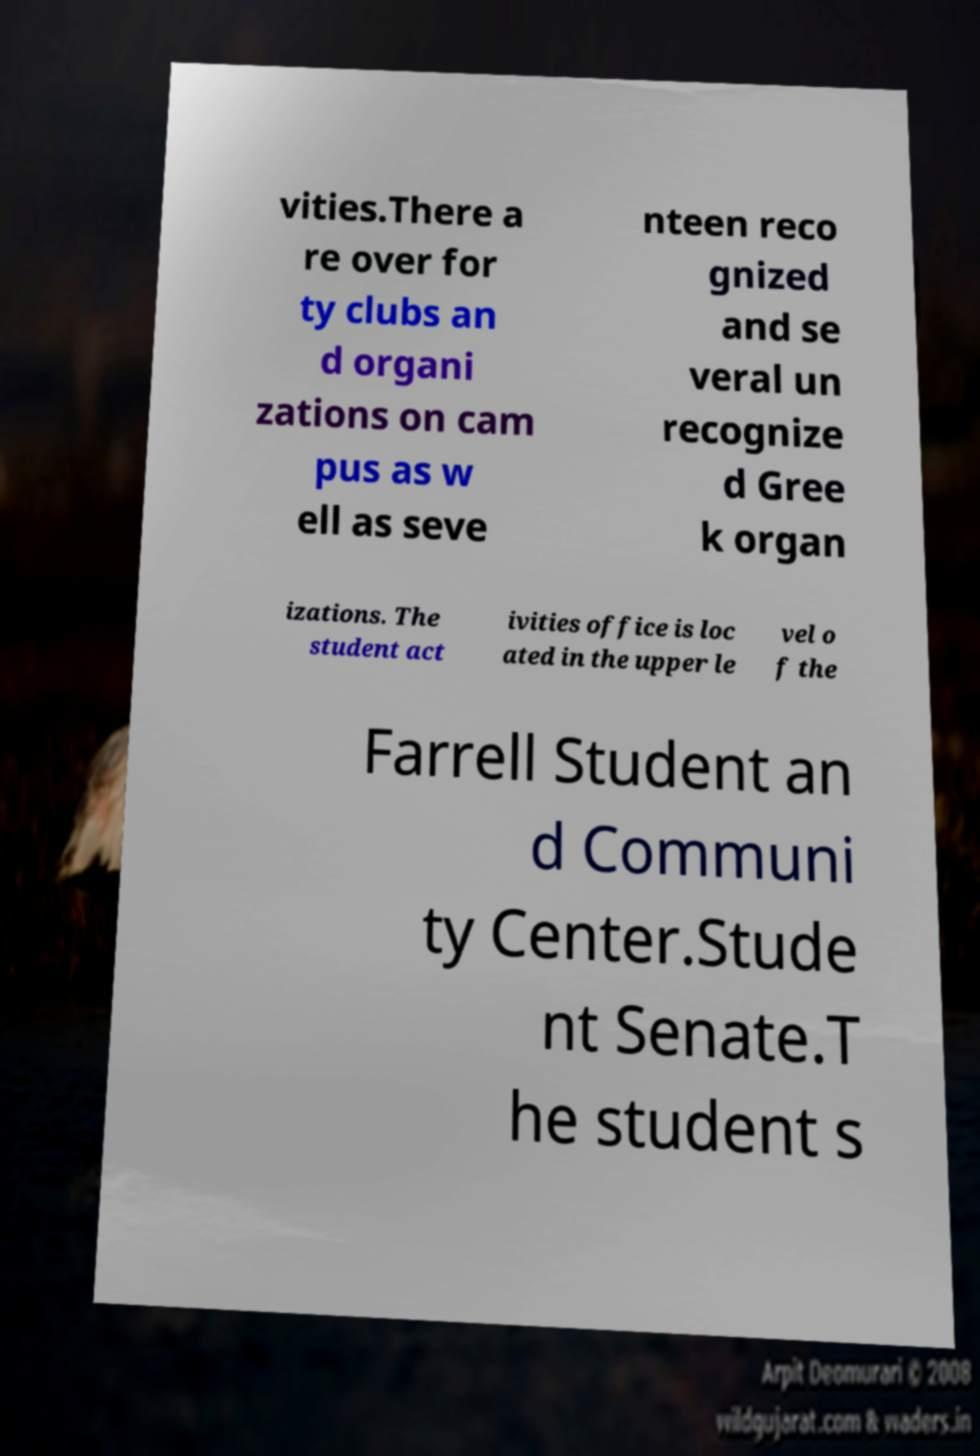Please identify and transcribe the text found in this image. vities.There a re over for ty clubs an d organi zations on cam pus as w ell as seve nteen reco gnized and se veral un recognize d Gree k organ izations. The student act ivities office is loc ated in the upper le vel o f the Farrell Student an d Communi ty Center.Stude nt Senate.T he student s 